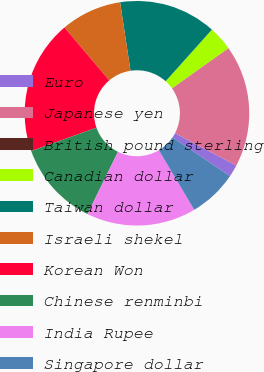Convert chart to OTSL. <chart><loc_0><loc_0><loc_500><loc_500><pie_chart><fcel>Euro<fcel>Japanese yen<fcel>British pound sterling<fcel>Canadian dollar<fcel>Taiwan dollar<fcel>Israeli shekel<fcel>Korean Won<fcel>Chinese renminbi<fcel>India Rupee<fcel>Singapore dollar<nl><fcel>1.76%<fcel>17.54%<fcel>0.01%<fcel>3.52%<fcel>14.03%<fcel>8.77%<fcel>19.29%<fcel>12.28%<fcel>15.78%<fcel>7.02%<nl></chart> 